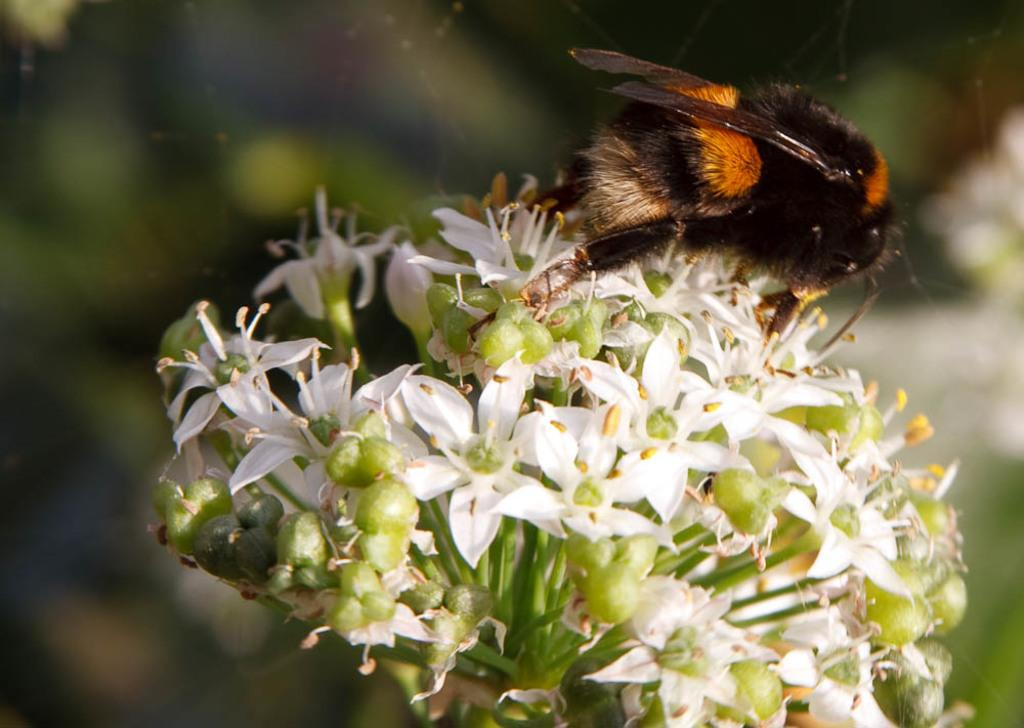What type of creature can be seen in the image? There is an insect in the image. Where is the insect located? The insect is on flowers. Can you describe the background of the image? The background of the image is blurred. What else can be seen in the image besides the insect? There are webs visible in the image. What type of land can be seen in the image? There is no land visible in the image; it features an insect on flowers with a blurred background and visible webs. Is there a cat present in the image? No, there is no cat present in the image. 